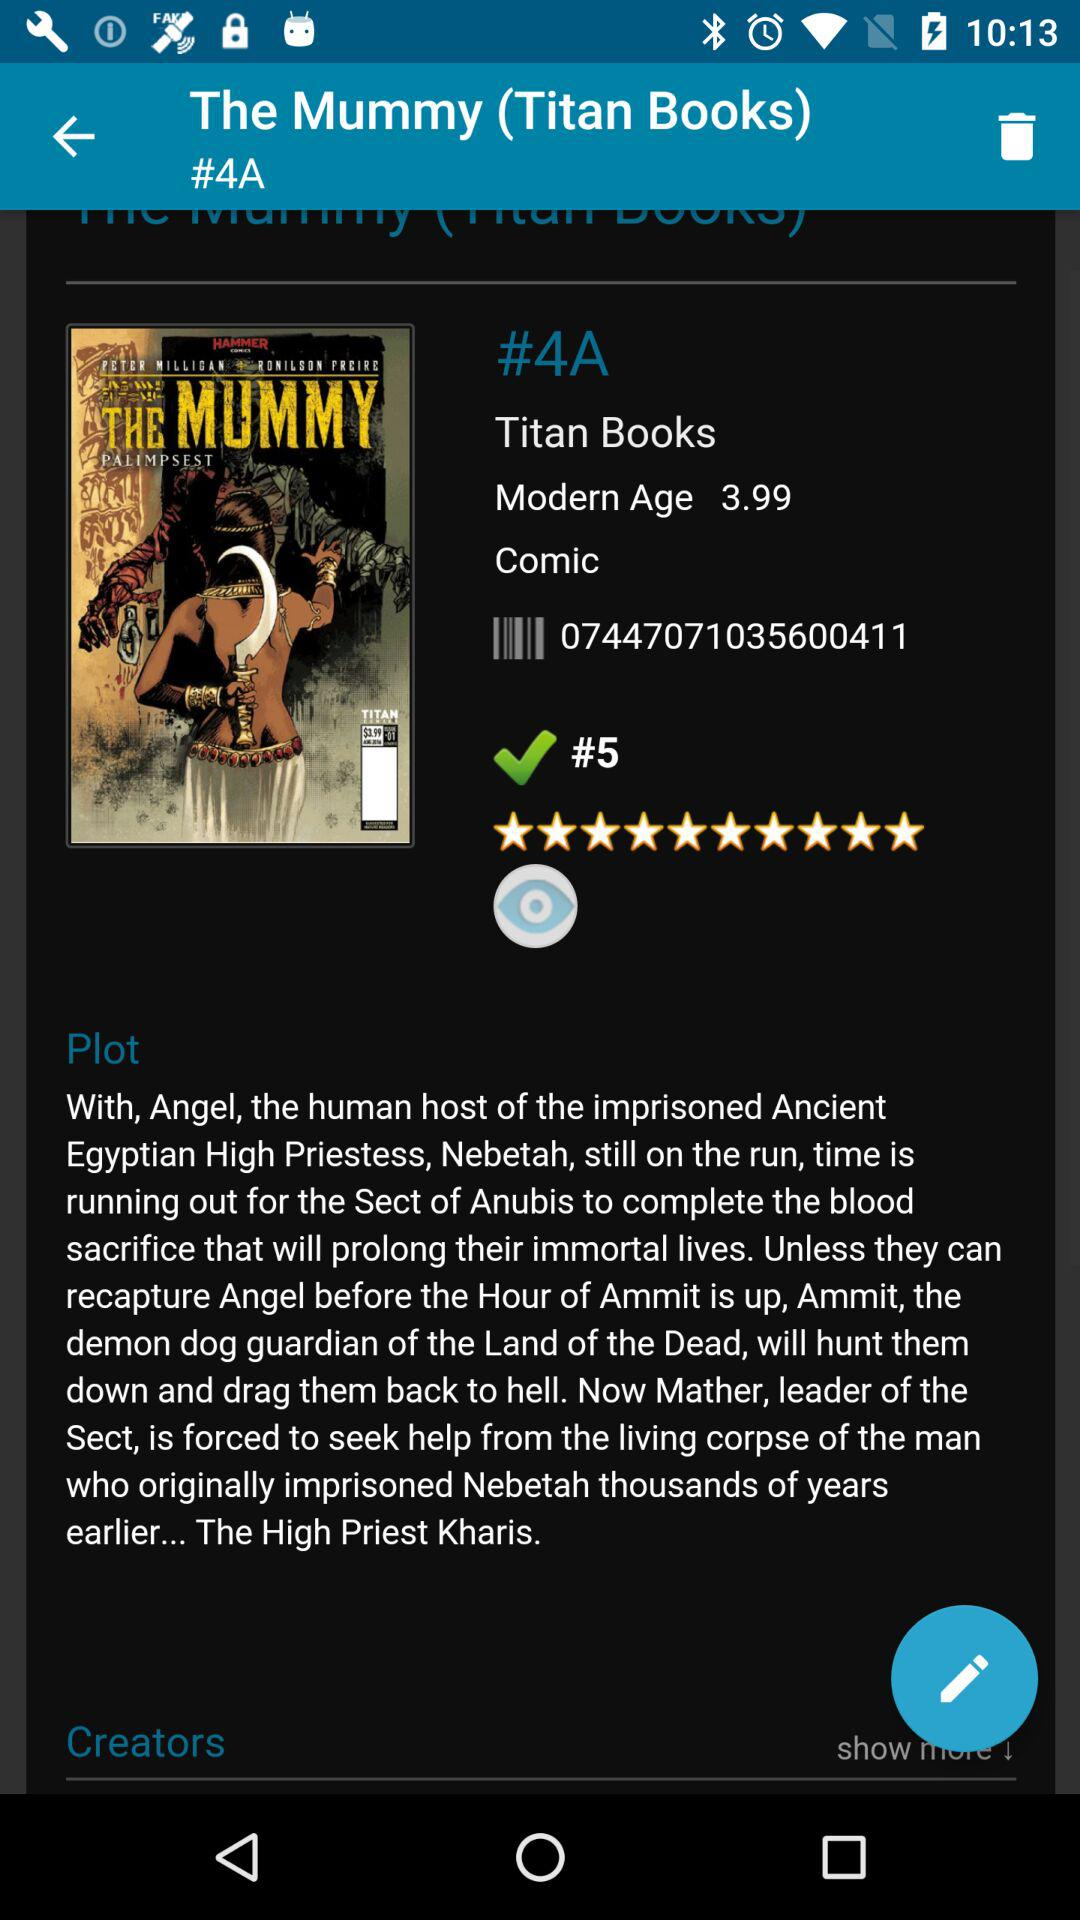What is the title of the book? The title of the book is "The Mummy". 